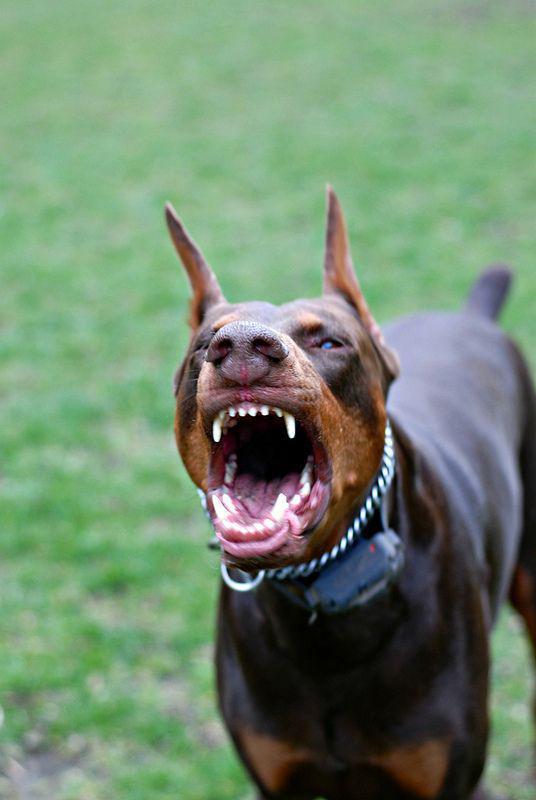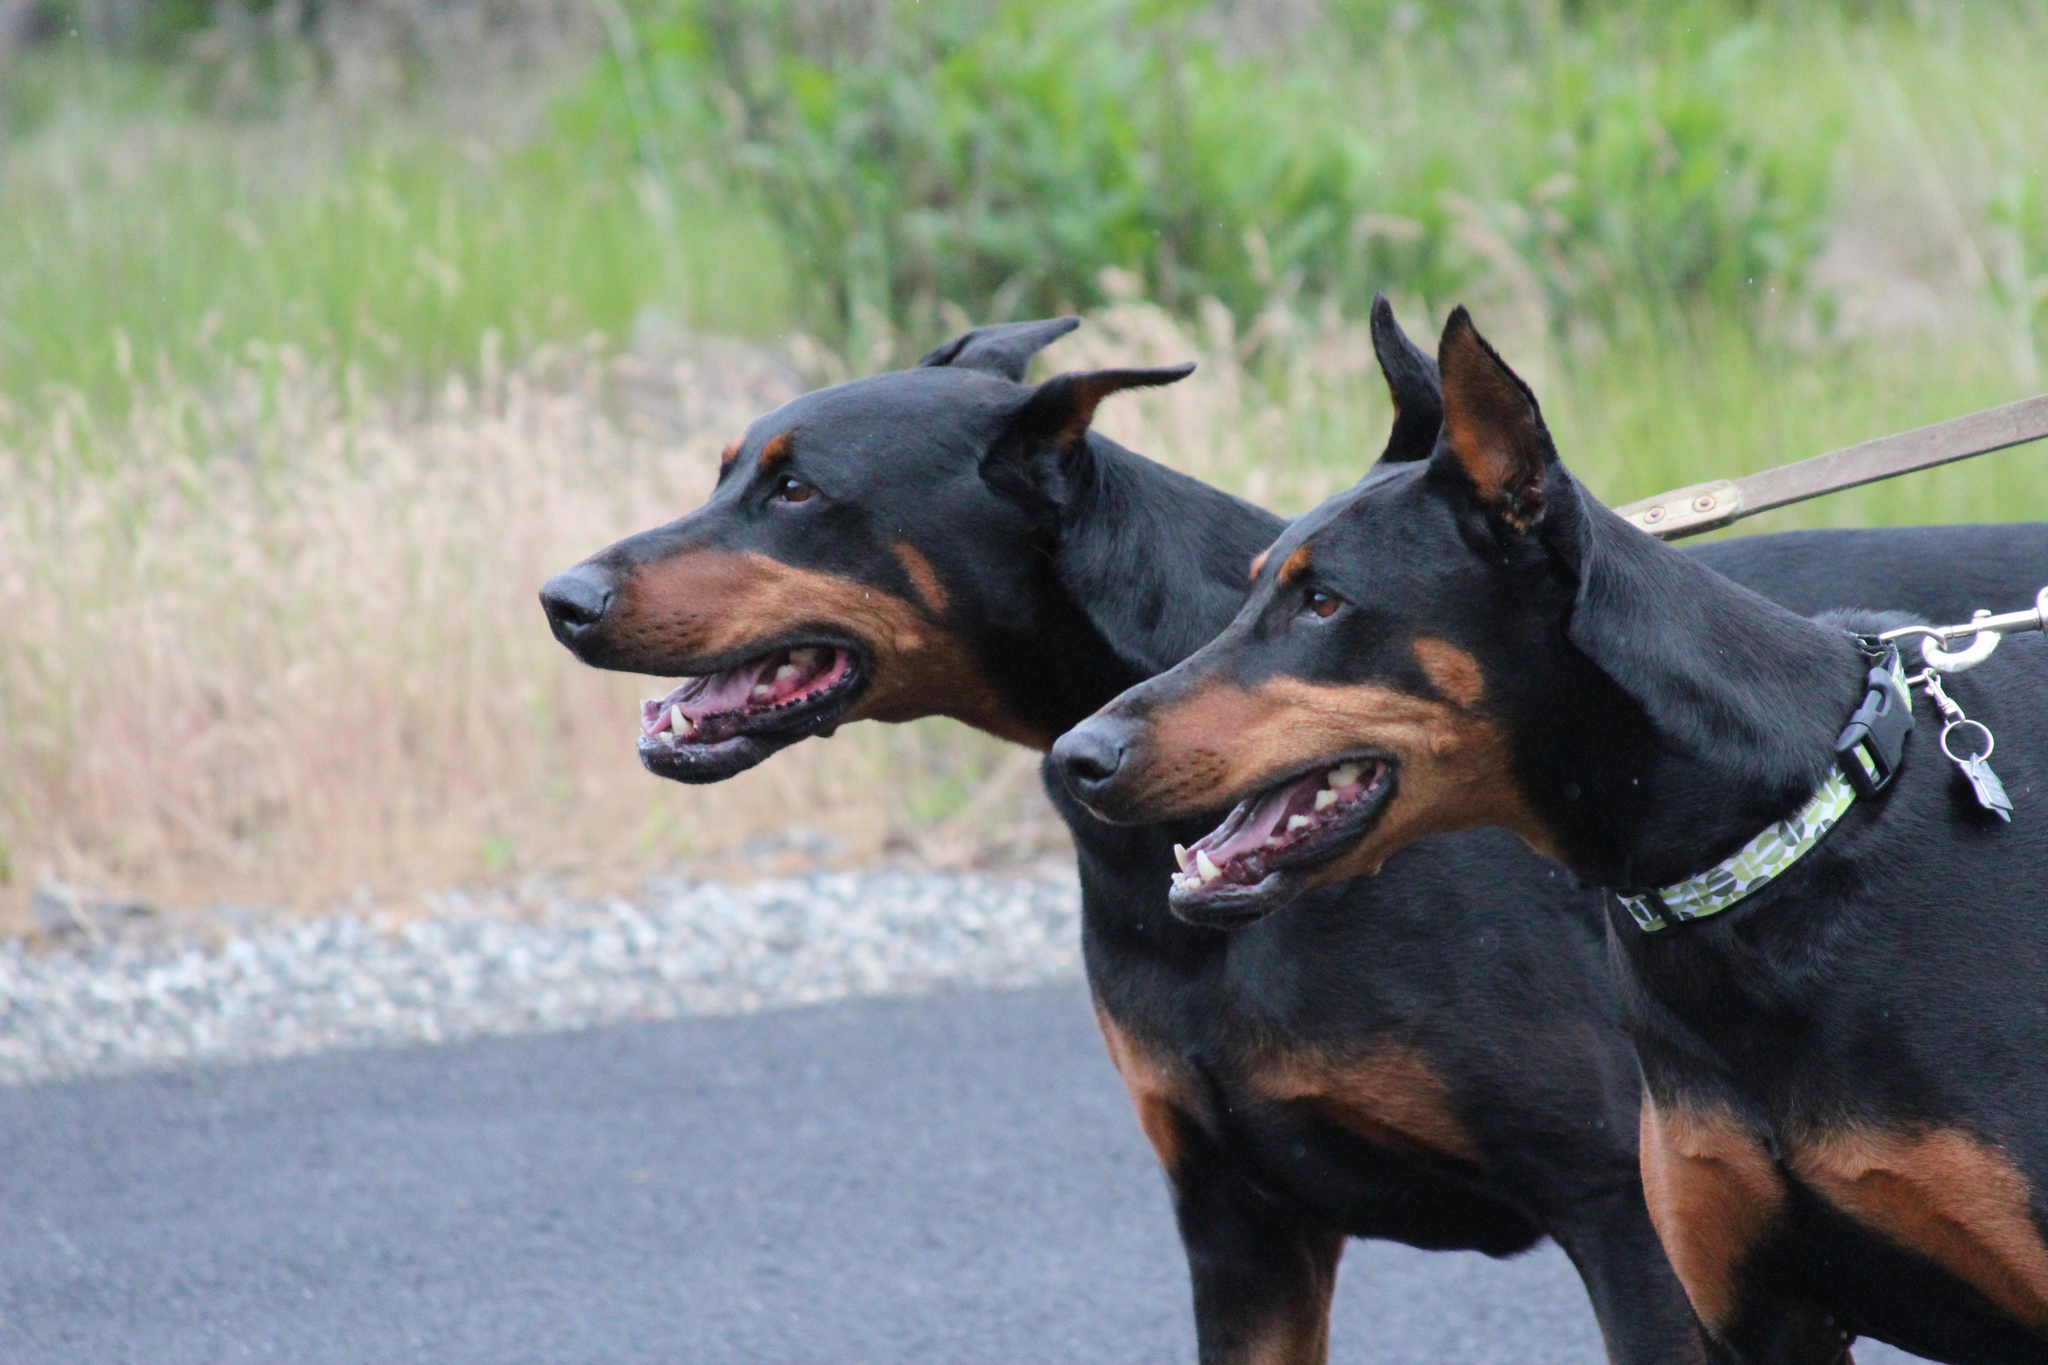The first image is the image on the left, the second image is the image on the right. Given the left and right images, does the statement "A doberman has its mouth open." hold true? Answer yes or no. Yes. The first image is the image on the left, the second image is the image on the right. Examine the images to the left and right. Is the description "The left image contains a doberman with its mouth open wide and its fangs bared, and the right image contains at least one doberman with its body and gaze facing left." accurate? Answer yes or no. Yes. 